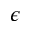Convert formula to latex. <formula><loc_0><loc_0><loc_500><loc_500>\epsilon</formula> 